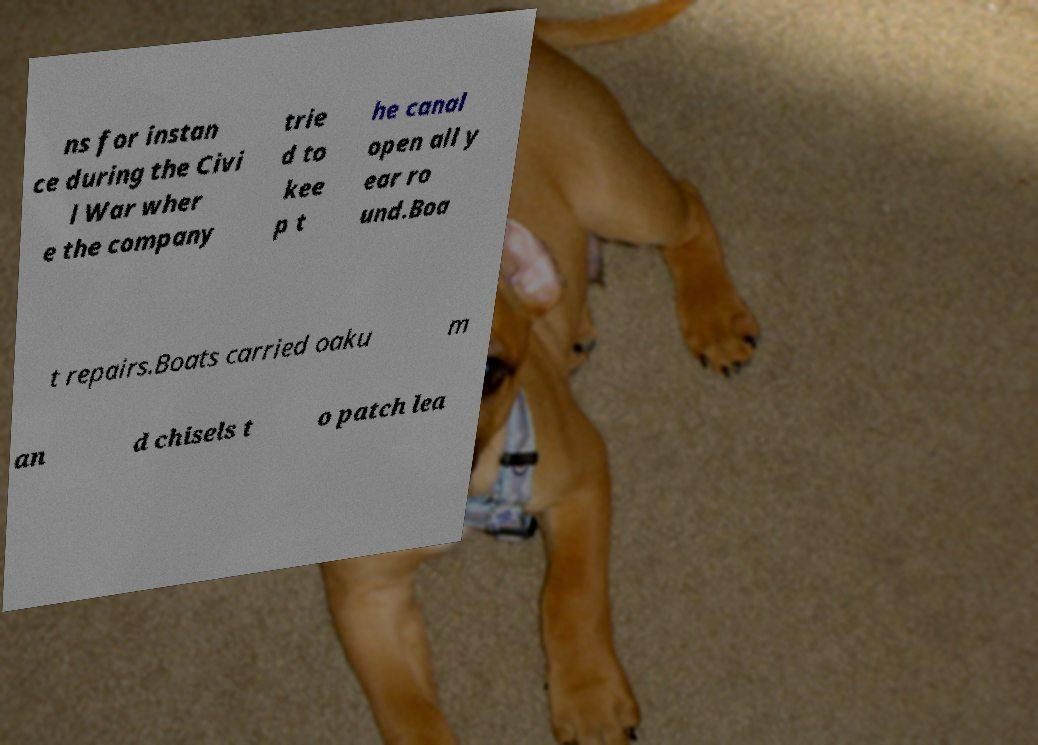Could you extract and type out the text from this image? ns for instan ce during the Civi l War wher e the company trie d to kee p t he canal open all y ear ro und.Boa t repairs.Boats carried oaku m an d chisels t o patch lea 